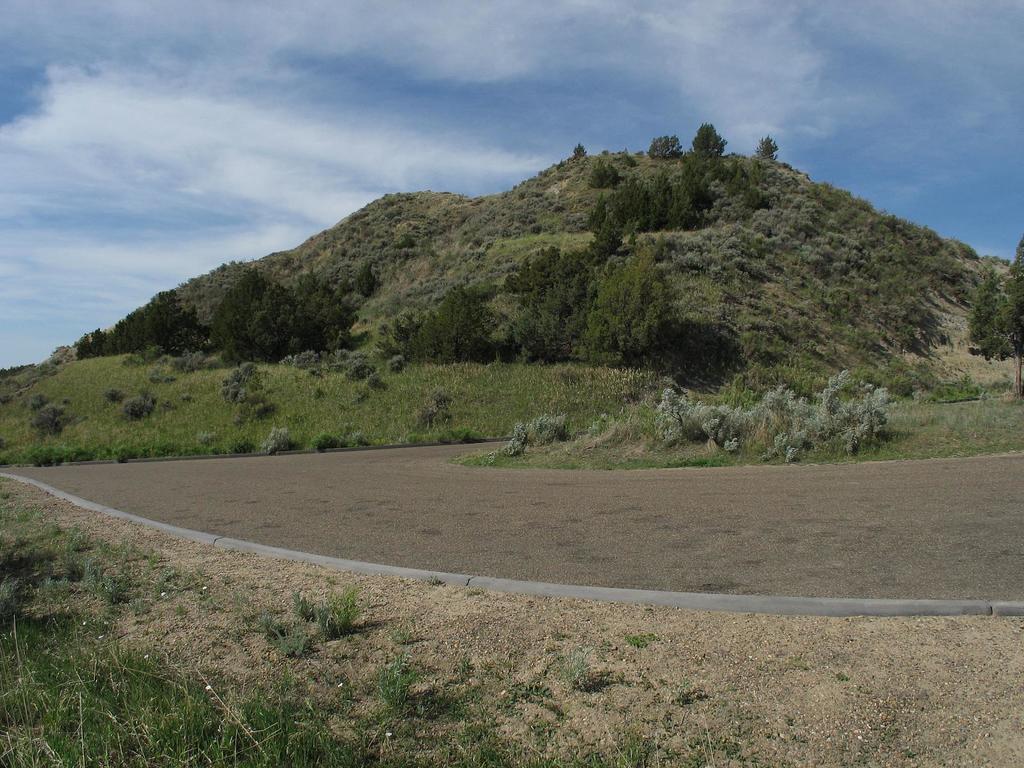Could you give a brief overview of what you see in this image? In the center of the image we can see the hill, trees. At the bottom of the image we can see the road, plants, sand. At the top of the image we can see the clouds in the sky. 